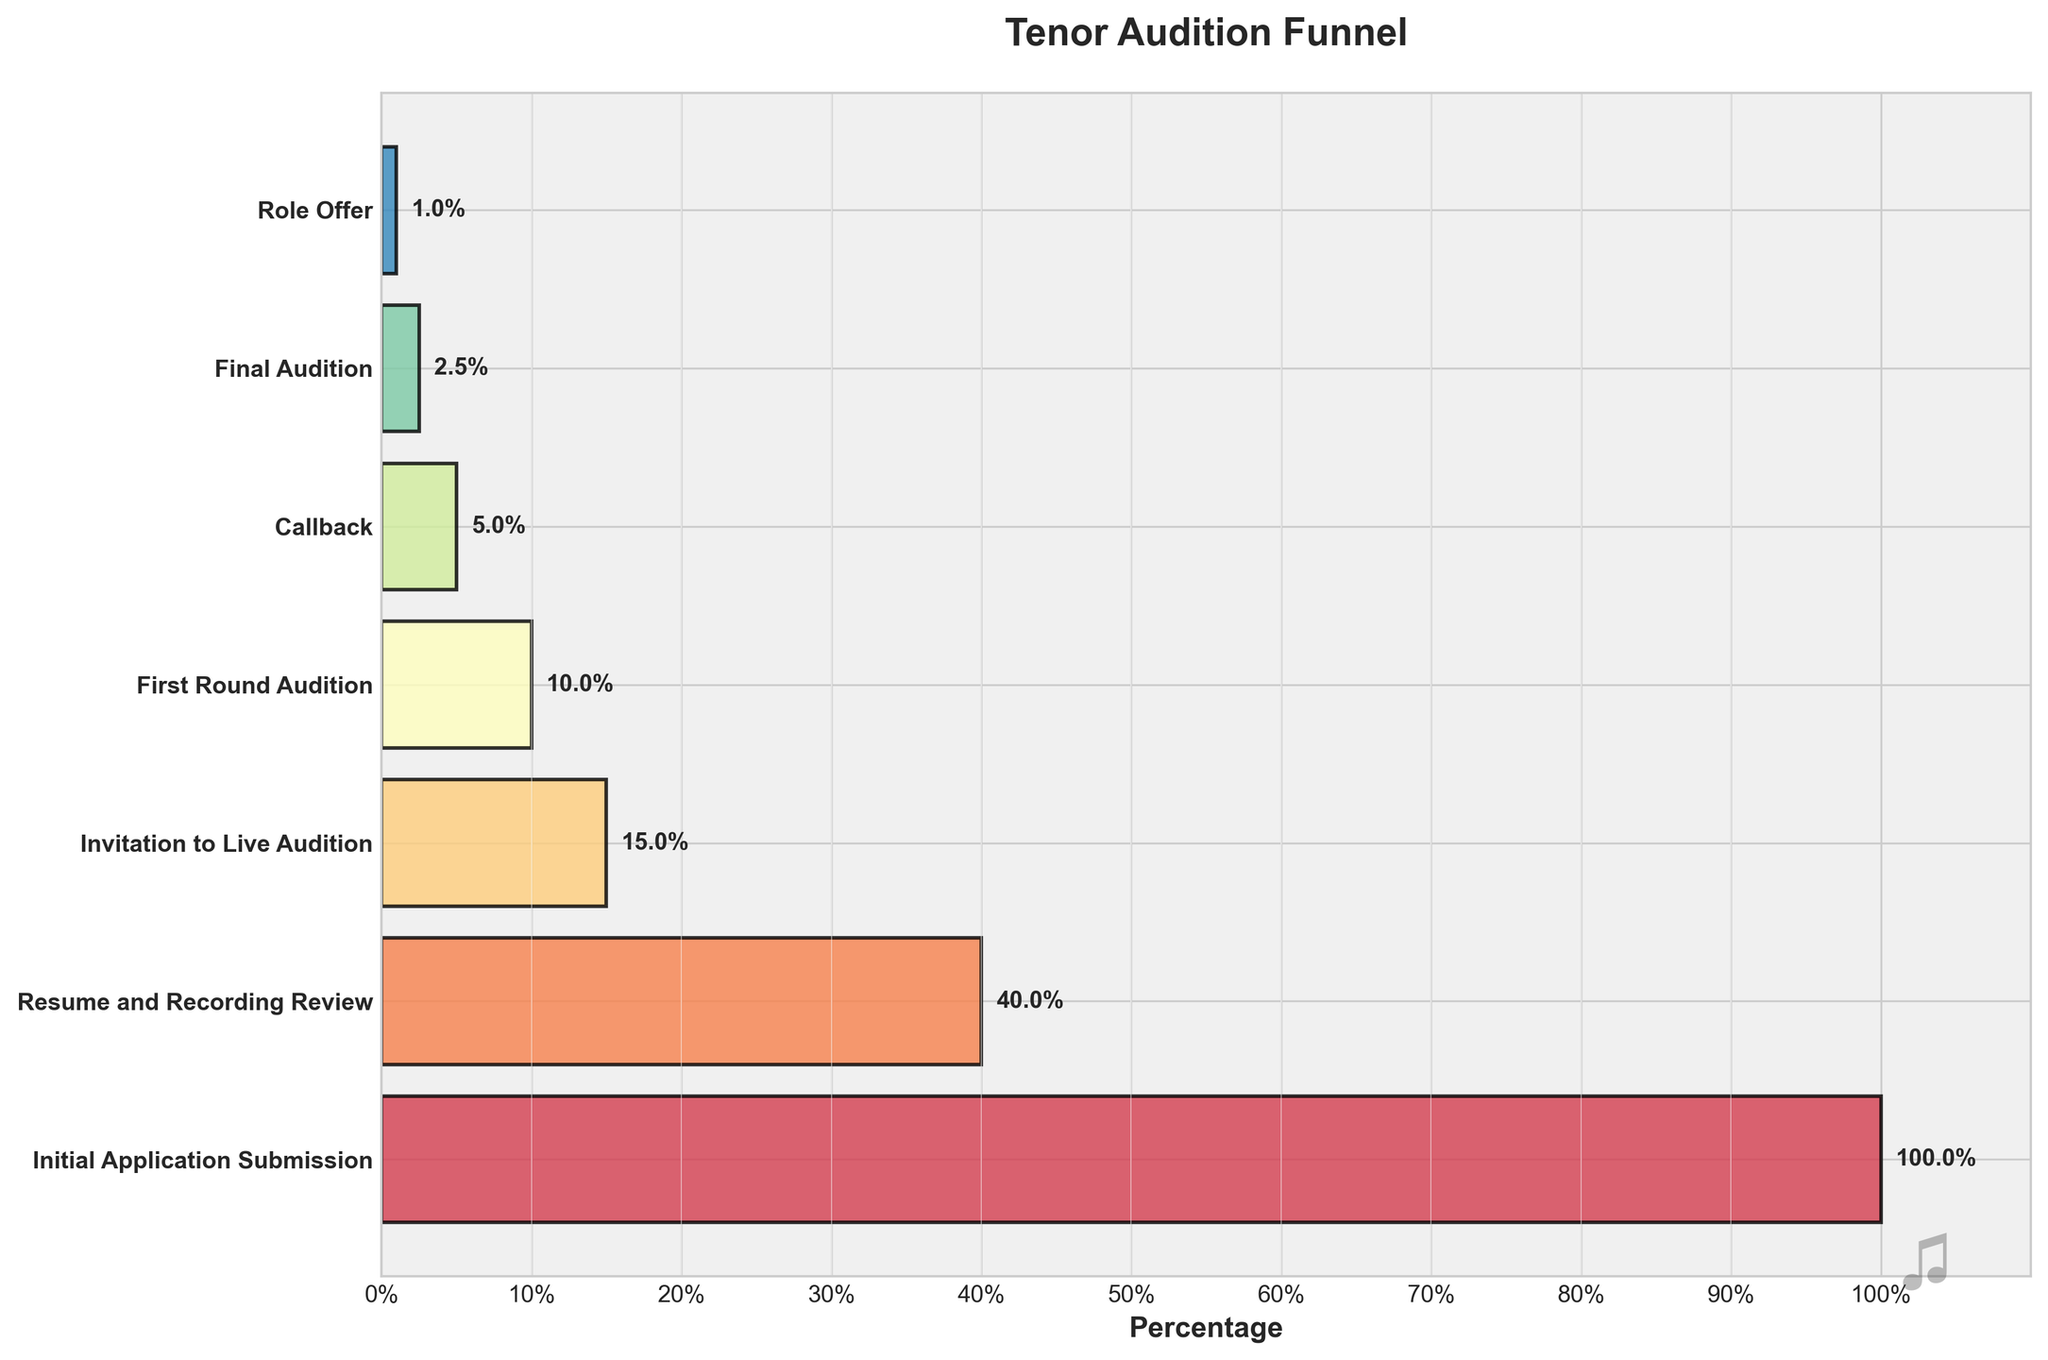How many stages are depicted in the funnel chart? The funnel chart shows the vertical bars representing the different stages of the audition process. Count the stages in the y-axis labels.
Answer: 7 Which stage has the highest percentage of applicants? Look at the width of the bars, where a wider bar indicates a higher percentage of applicants. The widest bar corresponds to the "Initial Application Submission" stage.
Answer: Initial Application Submission What percentage of applicants make it to the final audition? Identify the bar labeled "Final Audition" and refer to its corresponding percentage.
Answer: 2.5% How many applicants are invited to the live audition? Find the stage labeled "Invitation to Live Audition" and check the number of applicants listed for that stage.
Answer: 150 What is the difference in percentage between the initial application submission and the first-round audition? Subtract the percentage of the "First Round Audition" stage from the "Initial Application Submission" stage: 100% - 10%.
Answer: 90% Which stages see a reduction of more than 50% in the number of applicants when compared to the previous stage? Compare the percentages of adjacent stages to identify those with a reduction greater than 50%. This occurs between "Initial Application Submission" (100%) to "Resume and Recording Review" (40%) and "Resume and Recording Review" (40%) to "Invitation to Live Audition" (15%).
Answer: 2 stages What is the percentage reduction from the first round audition to the role offer stage? Subtract the final stage percentage ("Role Offer" at 1%) from the "First Round Audition" percentage (10%) and note the reduction: 10% - 1%.
Answer: 9% If 1000 applicants submit their initial application, how many eventually receive a role offer? Use the percentage for the "Role Offer" stage (1%) and calculate 1% of 1000.
Answer: 10 Which stage shows the smallest drop in the number of applicants from the previous stage? Compare the numerical drops between stages to find the smallest one. The transition from "First Round Audition" (100 applicants) to "Callback" (50 applicants) has a reduction of 50.
Answer: First Round Audition to Callback How does the number of applicants change from the invitation to the live audition to receiving role offers? Compare the number of applicants at the "Invitation to Live Audition" stage (150) and the "Role Offer" stage (10) to calculate the change: 150 - 10.
Answer: 140 